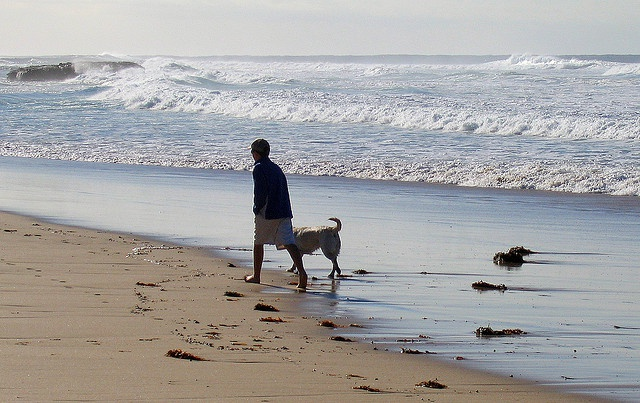Describe the objects in this image and their specific colors. I can see people in lightgray, black, navy, and darkgray tones and dog in lightgray, black, gray, and darkgray tones in this image. 